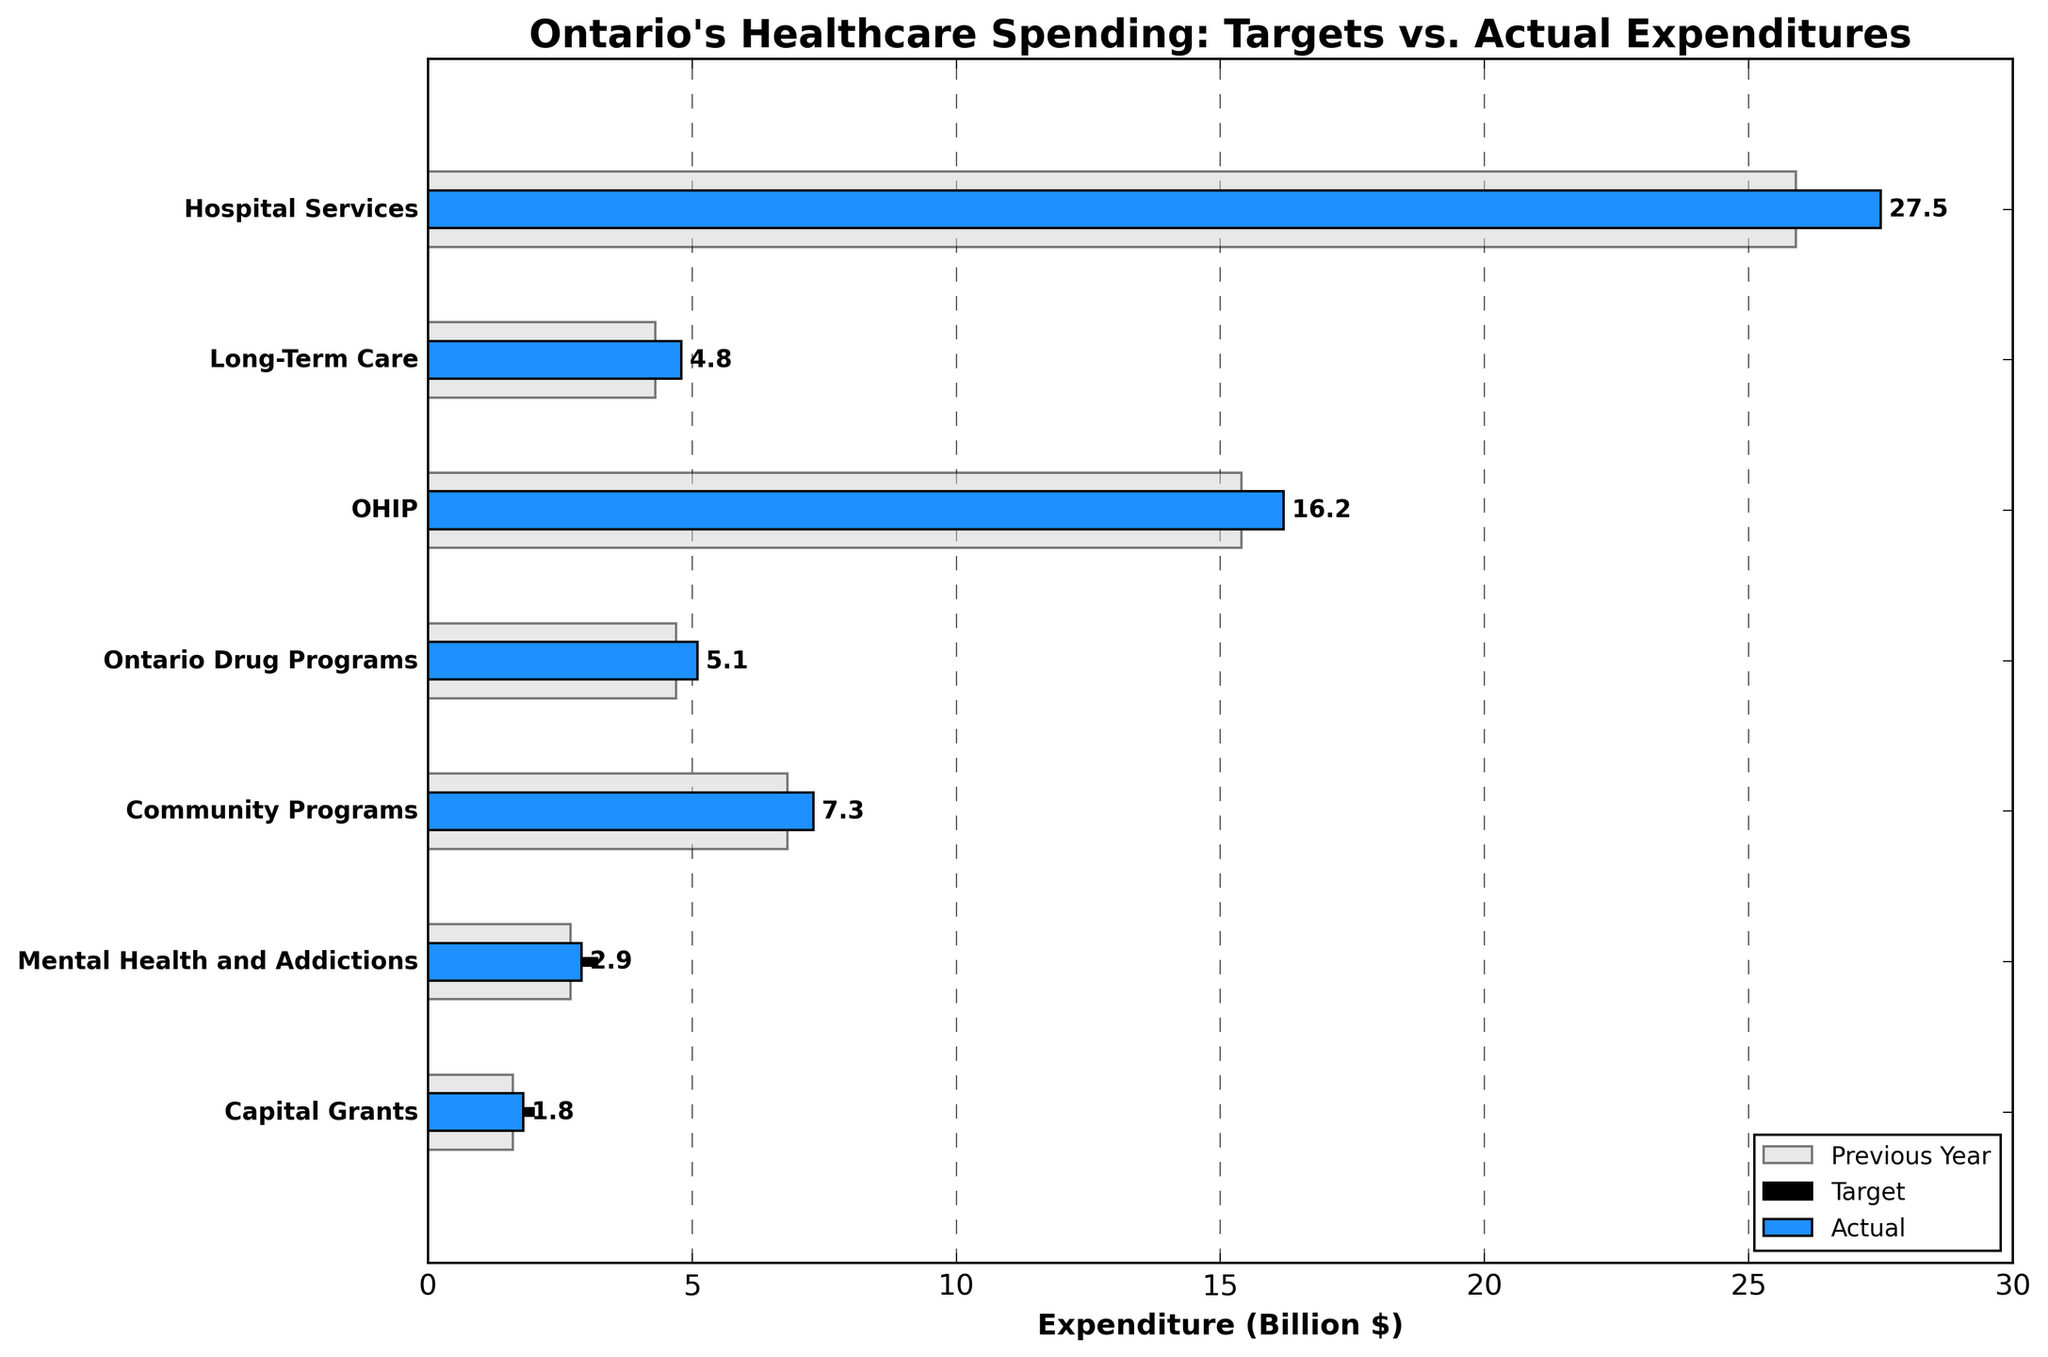What is the title of the chart? The title is displayed at the top of the chart and reads "Ontario's Healthcare Spending: Targets vs. Actual Expenditures".
Answer: Ontario's Healthcare Spending: Targets vs. Actual Expenditures Which healthcare category had the largest actual expenditure? The bars on the chart indicate the actual expenditures, and the largest bar corresponds to "Hospital Services" with a value of 27.5 billion dollars.
Answer: Hospital Services How much more was spent on Ontario Drug Programs compared to the previous year? The chart shows the actual expenditure for the current year and the previous year. For Ontario Drug Programs, the actual expenditure is 5.1 and the previous year's expenditure is 4.7. The difference is 5.1 - 4.7 = 0.4 billion dollars.
Answer: 0.4 billion dollars Which category came closest to meeting its target expenditure? The categories with actual expenditures closest to their targets have their bars and target lines nearly overlapping. "Long-Term Care" is closest with actual expenditure of 4.8 compared to a target of 4.5.
Answer: Long-Term Care Which category had its actual expenditure below the target? Looking at the chart, "Mental Health and Addictions" is the category where the actual expenditure (2.9) is less than the target (3.2).
Answer: Mental Health and Addictions What is the total actual expenditure across all categories? To find the total, sum up all the actual expenditures specified for each category: 27.5 (Hospital Services) + 4.8 (Long-Term Care) + 16.2 (OHIP) + 5.1 (Ontario Drug Programs) + 7.3 (Community Programs) + 2.9 (Mental Health and Addictions) + 1.8 (Capital Grants) = 65.6 billion dollars.
Answer: 65.6 billion dollars How does the actual spending on Community Programs compare to the previous year? The chart indicates the actual expenditure of 7.3 billion dollars this year and the previous year's expenditure as 6.8 billion dollars. Comparing these, the change is 7.3 - 6.8 = 0.5 billion dollars higher this year.
Answer: 0.5 billion dollars higher By how much did the actual expenditure on Hospital Services exceed its target? The actual expenditure for Hospital Services is 27.5 billion dollars, and the target is 26.8 billion dollars. The difference is 27.5 - 26.8 = 0.7 billion dollars.
Answer: 0.7 billion dollars What were the total projected target expenditures across all categories? To find the total target expenditures, sum up the target values: 26.8 (Hospital Services) + 4.5 (Long-Term Care) + 15.7 (OHIP) + 4.9 (Ontario Drug Programs) + 7.0 (Community Programs) + 3.2 (Mental Health and Addictions) + 2.0 (Capital Grants) = 64.1 billion dollars.
Answer: 64.1 billion dollars 